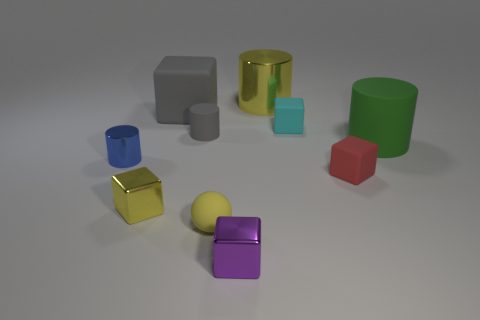If these objects were part of a game, what could be the rules? If these objects were part of a game, it could be a sorting or matching challenge where players must group objects by shape, color, or material properties, adding complexity by using attributes like size or the object's finish—matte or glossy. 